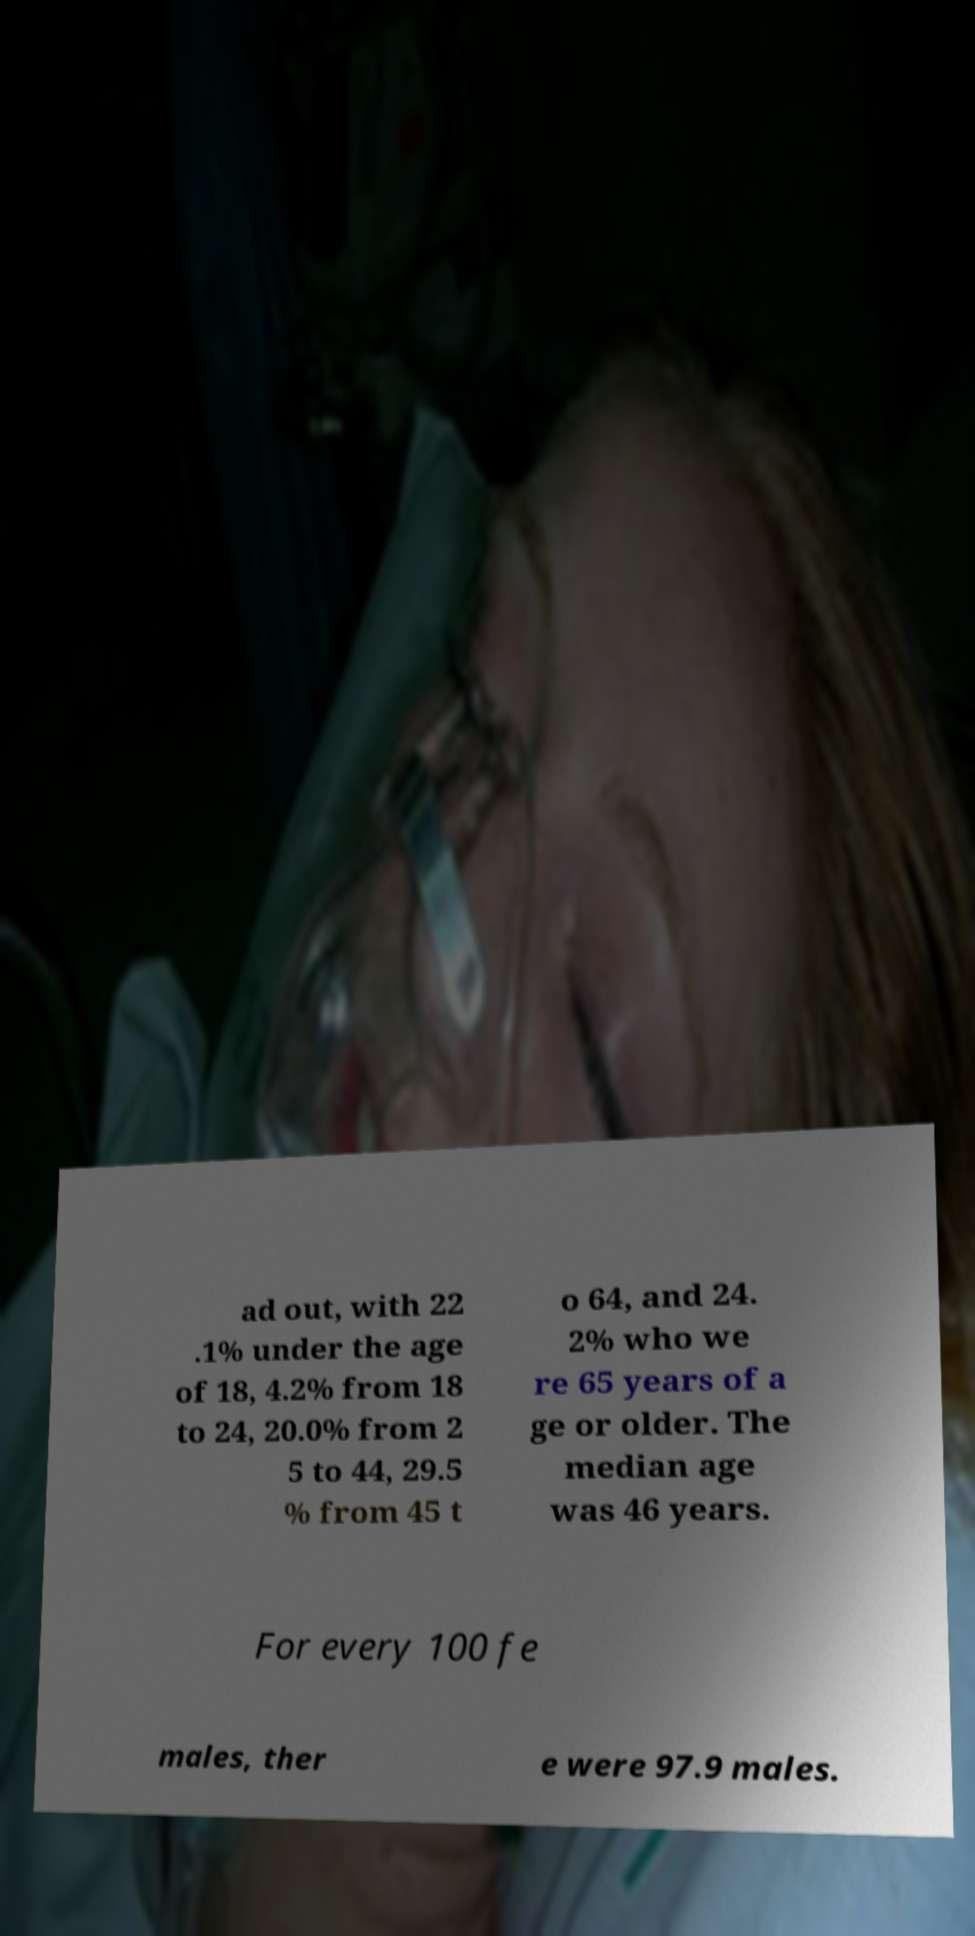I need the written content from this picture converted into text. Can you do that? ad out, with 22 .1% under the age of 18, 4.2% from 18 to 24, 20.0% from 2 5 to 44, 29.5 % from 45 t o 64, and 24. 2% who we re 65 years of a ge or older. The median age was 46 years. For every 100 fe males, ther e were 97.9 males. 